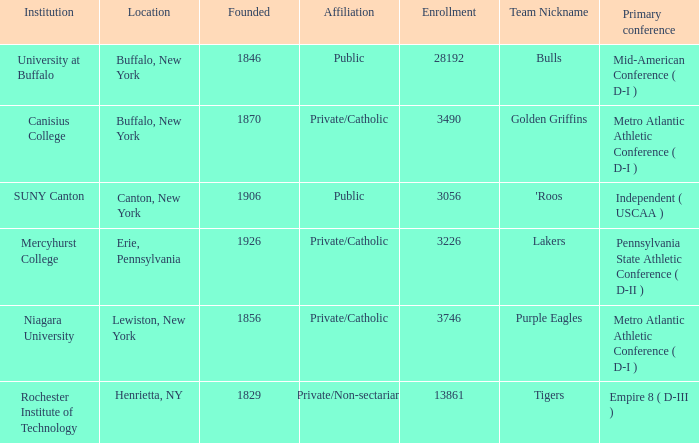What was the enrollment of the school initiated in 1846? 28192.0. 